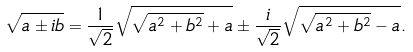Convert formula to latex. <formula><loc_0><loc_0><loc_500><loc_500>\sqrt { a \pm i b } = \frac { 1 } { \sqrt { 2 } } \sqrt { \sqrt { a ^ { 2 } + b ^ { 2 } } + a } \pm \frac { i } { \sqrt { 2 } } \sqrt { \sqrt { a ^ { 2 } + b ^ { 2 } } - a } .</formula> 